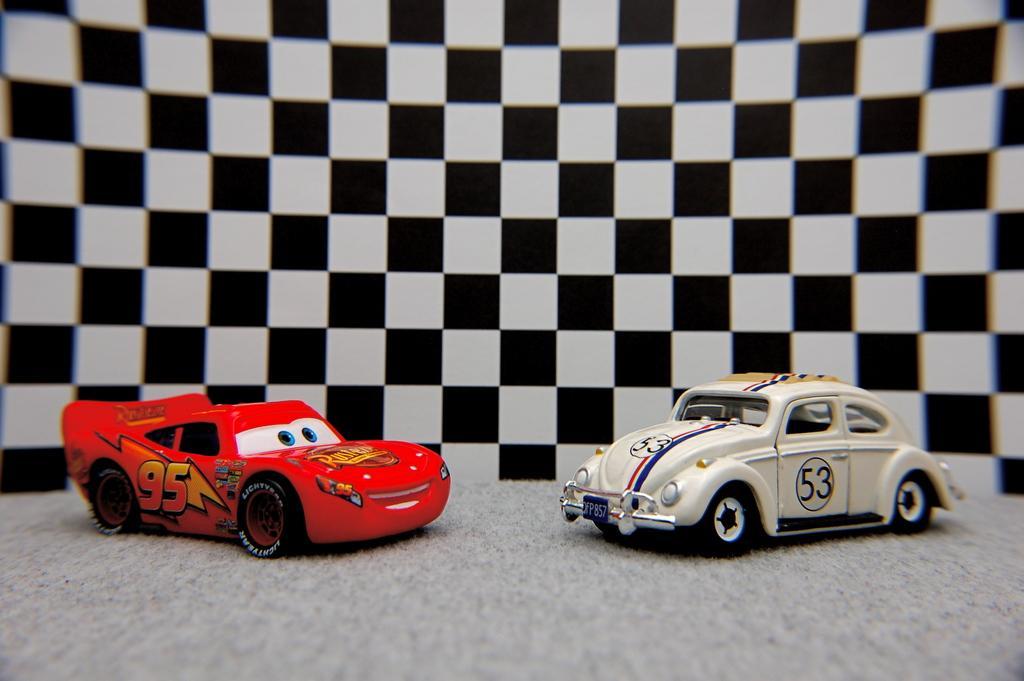Please provide a concise description of this image. In this image we can see toy cars. In the back there is a black and white check wall. 